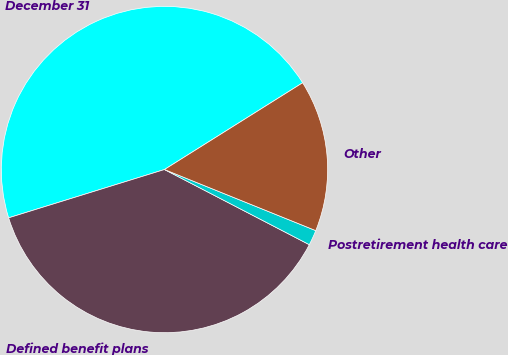Convert chart to OTSL. <chart><loc_0><loc_0><loc_500><loc_500><pie_chart><fcel>December 31<fcel>Defined benefit plans<fcel>Postretirement health care<fcel>Other<nl><fcel>45.86%<fcel>37.6%<fcel>1.51%<fcel>15.03%<nl></chart> 